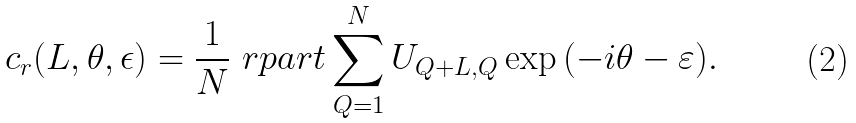<formula> <loc_0><loc_0><loc_500><loc_500>c _ { r } ( L , \theta , \epsilon ) = \frac { 1 } { N } \ r p a r t \sum ^ { N } _ { Q = 1 } U _ { Q + L , Q } \exp { ( - i \theta - \varepsilon ) } .</formula> 